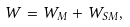<formula> <loc_0><loc_0><loc_500><loc_500>W = W _ { M } + W _ { S M } ,</formula> 